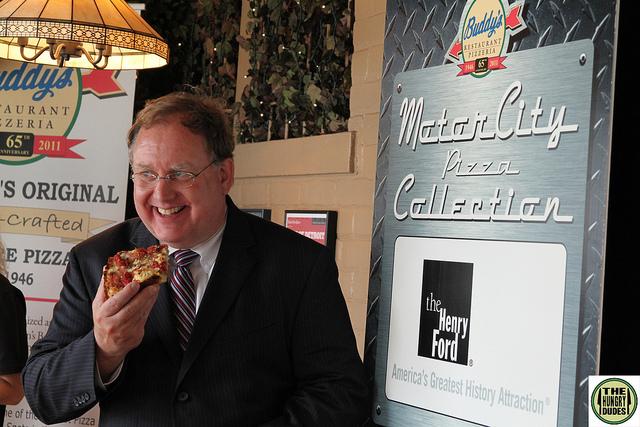How many years has the pizzeria been in business?
Write a very short answer. 65. What does the sign on the right say?
Short answer required. Motor city pizza collection. What type of pizza does the man have?
Short answer required. Pepperoni. 